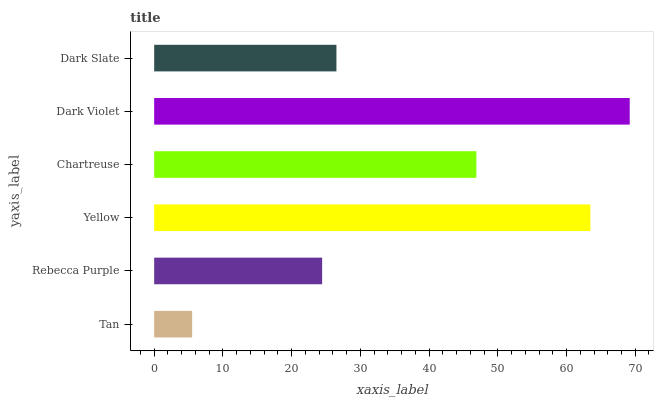Is Tan the minimum?
Answer yes or no. Yes. Is Dark Violet the maximum?
Answer yes or no. Yes. Is Rebecca Purple the minimum?
Answer yes or no. No. Is Rebecca Purple the maximum?
Answer yes or no. No. Is Rebecca Purple greater than Tan?
Answer yes or no. Yes. Is Tan less than Rebecca Purple?
Answer yes or no. Yes. Is Tan greater than Rebecca Purple?
Answer yes or no. No. Is Rebecca Purple less than Tan?
Answer yes or no. No. Is Chartreuse the high median?
Answer yes or no. Yes. Is Dark Slate the low median?
Answer yes or no. Yes. Is Rebecca Purple the high median?
Answer yes or no. No. Is Rebecca Purple the low median?
Answer yes or no. No. 